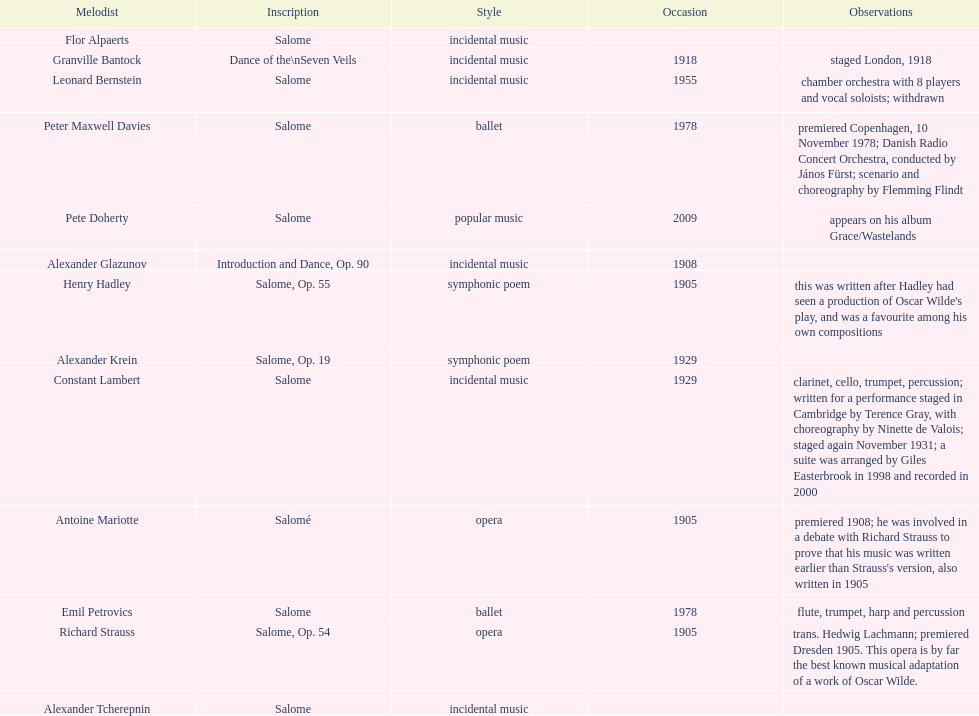Which composer published first granville bantock or emil petrovics? Granville Bantock. 